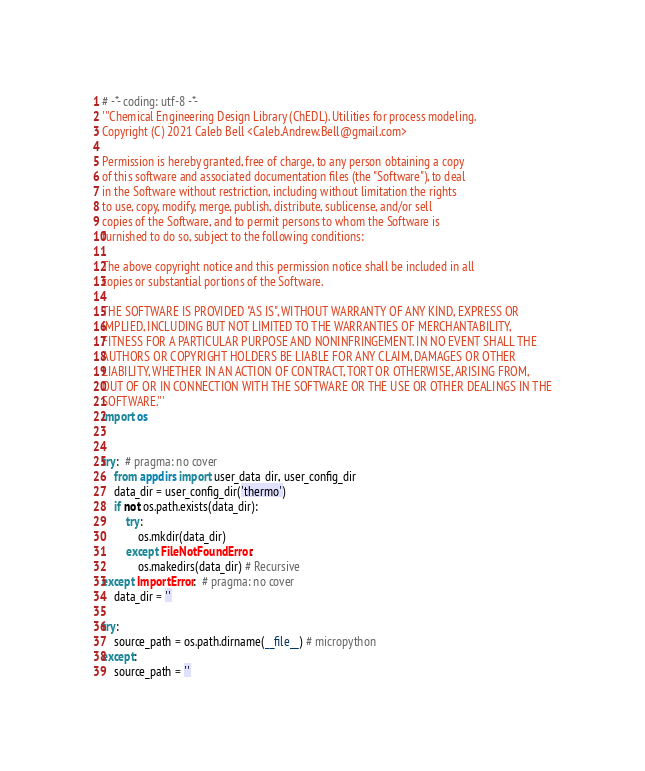<code> <loc_0><loc_0><loc_500><loc_500><_Python_># -*- coding: utf-8 -*-
'''Chemical Engineering Design Library (ChEDL). Utilities for process modeling.
Copyright (C) 2021 Caleb Bell <Caleb.Andrew.Bell@gmail.com>

Permission is hereby granted, free of charge, to any person obtaining a copy
of this software and associated documentation files (the "Software"), to deal
in the Software without restriction, including without limitation the rights
to use, copy, modify, merge, publish, distribute, sublicense, and/or sell
copies of the Software, and to permit persons to whom the Software is
furnished to do so, subject to the following conditions:

The above copyright notice and this permission notice shall be included in all
copies or substantial portions of the Software.

THE SOFTWARE IS PROVIDED "AS IS", WITHOUT WARRANTY OF ANY KIND, EXPRESS OR
IMPLIED, INCLUDING BUT NOT LIMITED TO THE WARRANTIES OF MERCHANTABILITY,
FITNESS FOR A PARTICULAR PURPOSE AND NONINFRINGEMENT. IN NO EVENT SHALL THE
AUTHORS OR COPYRIGHT HOLDERS BE LIABLE FOR ANY CLAIM, DAMAGES OR OTHER
LIABILITY, WHETHER IN AN ACTION OF CONTRACT, TORT OR OTHERWISE, ARISING FROM,
OUT OF OR IN CONNECTION WITH THE SOFTWARE OR THE USE OR OTHER DEALINGS IN THE
SOFTWARE.'''
import os


try:  # pragma: no cover
    from appdirs import user_data_dir, user_config_dir
    data_dir = user_config_dir('thermo')
    if not os.path.exists(data_dir):
        try:
            os.mkdir(data_dir)
        except FileNotFoundError:
            os.makedirs(data_dir) # Recursive
except ImportError:  # pragma: no cover
    data_dir = ''

try:
    source_path = os.path.dirname(__file__) # micropython
except:
    source_path = ''
</code> 